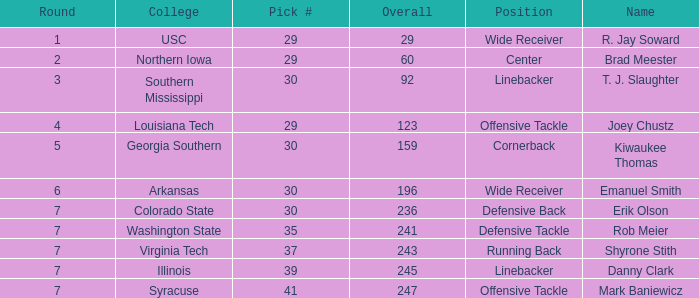Could you parse the entire table? {'header': ['Round', 'College', 'Pick #', 'Overall', 'Position', 'Name'], 'rows': [['1', 'USC', '29', '29', 'Wide Receiver', 'R. Jay Soward'], ['2', 'Northern Iowa', '29', '60', 'Center', 'Brad Meester'], ['3', 'Southern Mississippi', '30', '92', 'Linebacker', 'T. J. Slaughter'], ['4', 'Louisiana Tech', '29', '123', 'Offensive Tackle', 'Joey Chustz'], ['5', 'Georgia Southern', '30', '159', 'Cornerback', 'Kiwaukee Thomas'], ['6', 'Arkansas', '30', '196', 'Wide Receiver', 'Emanuel Smith'], ['7', 'Colorado State', '30', '236', 'Defensive Back', 'Erik Olson'], ['7', 'Washington State', '35', '241', 'Defensive Tackle', 'Rob Meier'], ['7', 'Virginia Tech', '37', '243', 'Running Back', 'Shyrone Stith'], ['7', 'Illinois', '39', '245', 'Linebacker', 'Danny Clark'], ['7', 'Syracuse', '41', '247', 'Offensive Tackle', 'Mark Baniewicz']]} What is the lowest Round with Overall of 247 and pick less than 41? None. 